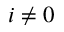Convert formula to latex. <formula><loc_0><loc_0><loc_500><loc_500>i \neq 0</formula> 